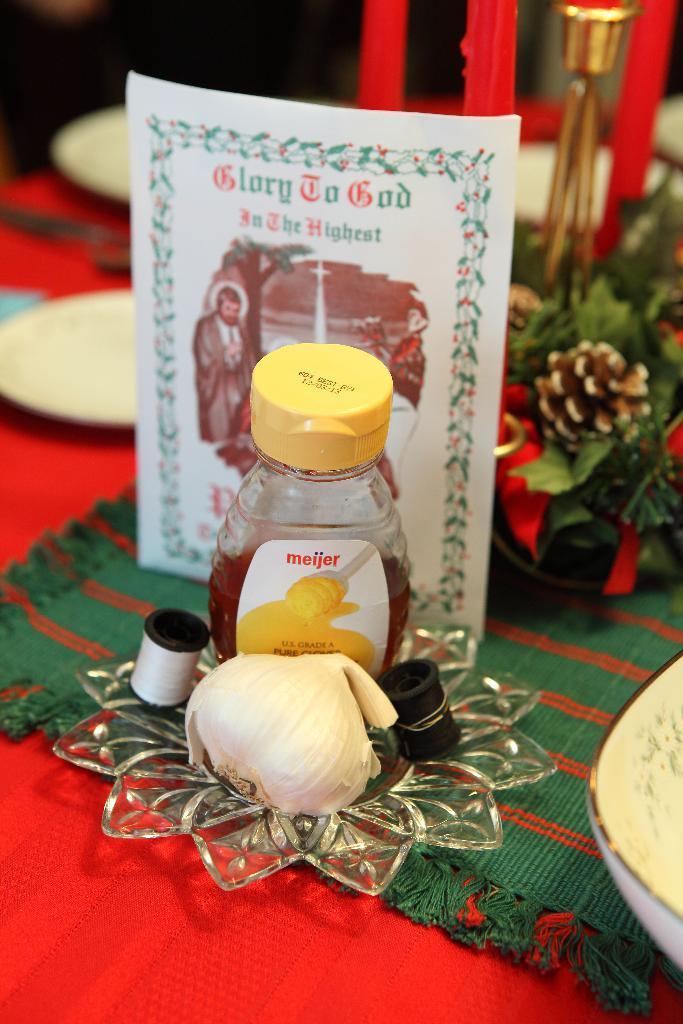How would you summarize this image in a sentence or two? In this image there is a bowl in the bottom right corner of this image,and there is a bottle and a white color paper is in the middle of this image. There are some flowers on the right side of this image,and there are some white color plates on the left side of this image. There are some other objects as we can see in the bottom of this image. 